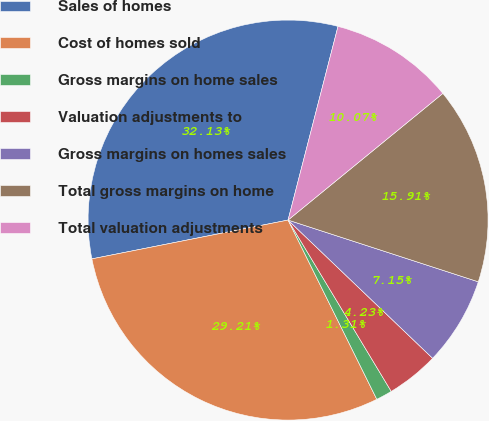Convert chart to OTSL. <chart><loc_0><loc_0><loc_500><loc_500><pie_chart><fcel>Sales of homes<fcel>Cost of homes sold<fcel>Gross margins on home sales<fcel>Valuation adjustments to<fcel>Gross margins on homes sales<fcel>Total gross margins on home<fcel>Total valuation adjustments<nl><fcel>32.13%<fcel>29.21%<fcel>1.31%<fcel>4.23%<fcel>7.15%<fcel>15.91%<fcel>10.07%<nl></chart> 